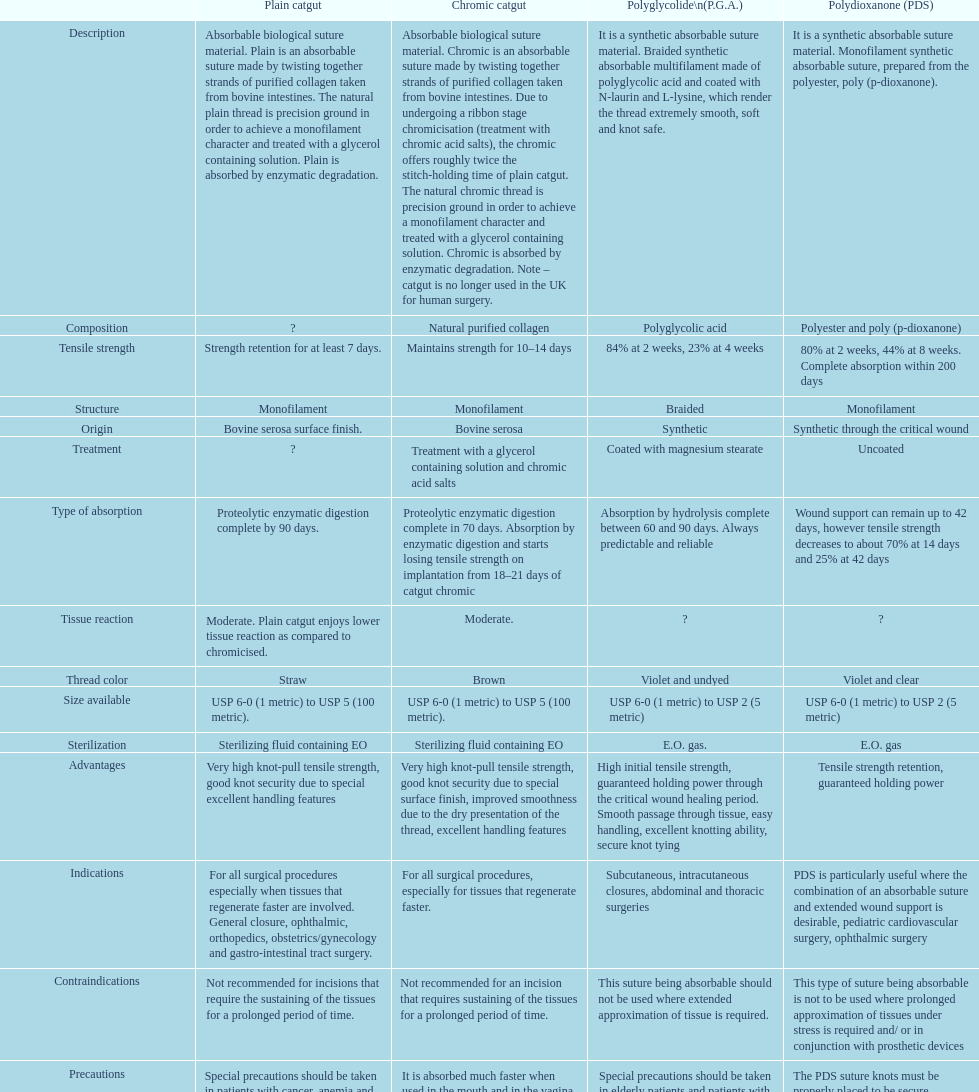What category of sutures have been discontinued for human surgery in the u.k.? Chromic catgut. 